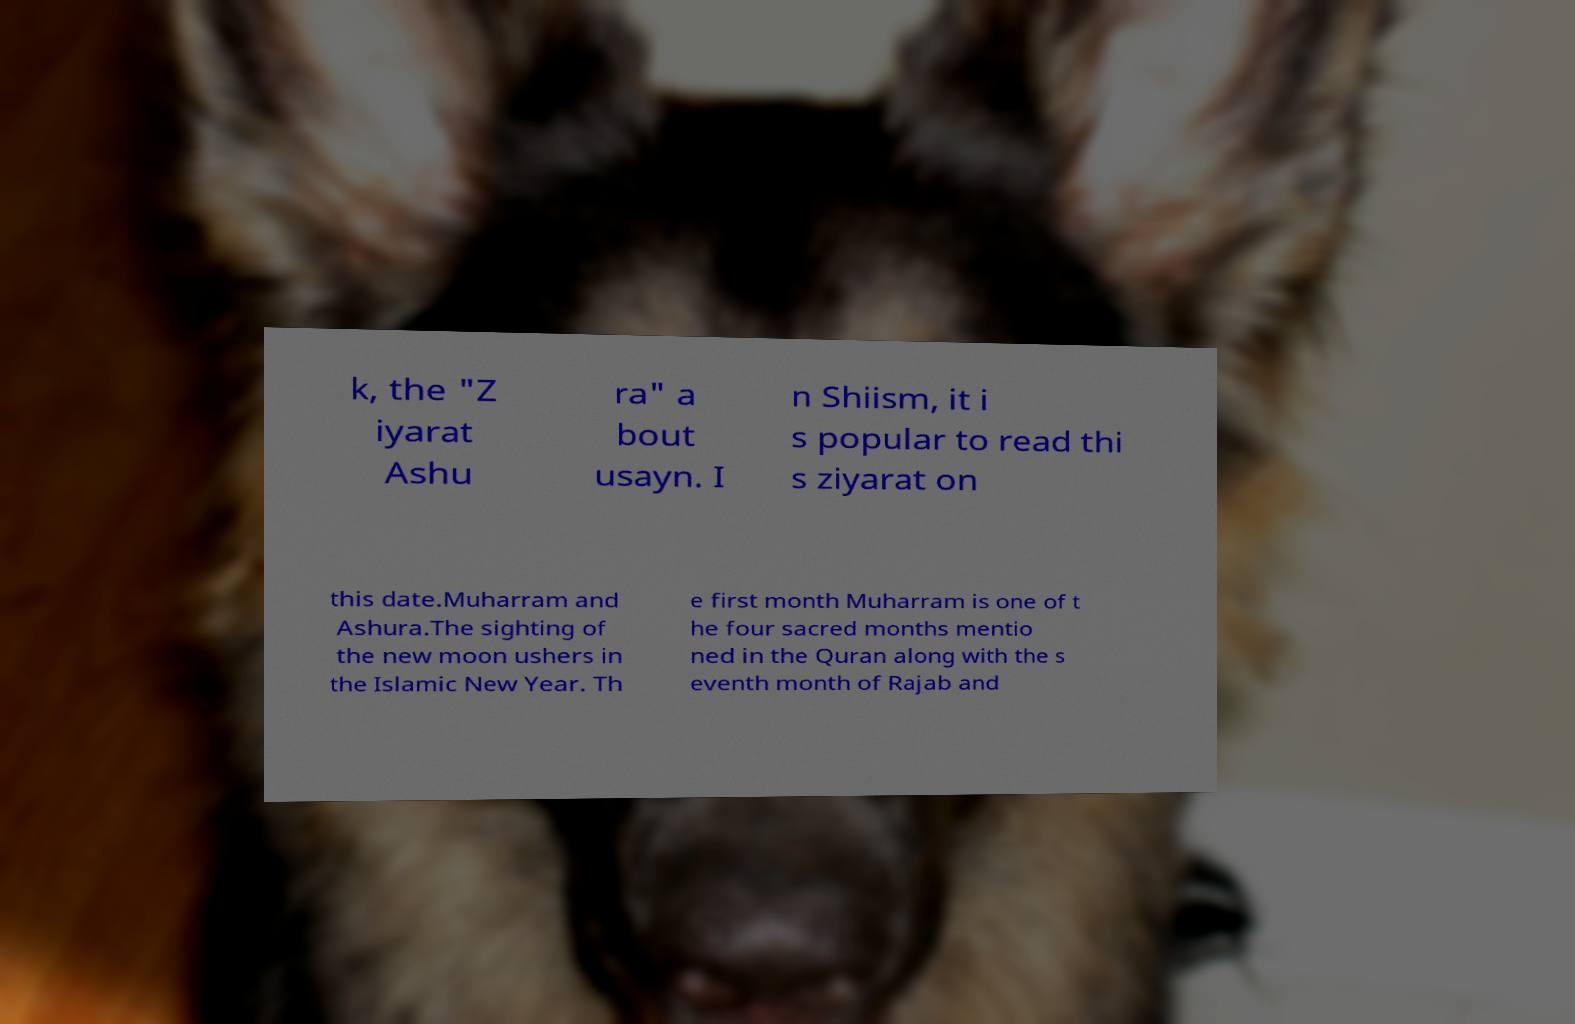I need the written content from this picture converted into text. Can you do that? k, the "Z iyarat Ashu ra" a bout usayn. I n Shiism, it i s popular to read thi s ziyarat on this date.Muharram and Ashura.The sighting of the new moon ushers in the Islamic New Year. Th e first month Muharram is one of t he four sacred months mentio ned in the Quran along with the s eventh month of Rajab and 